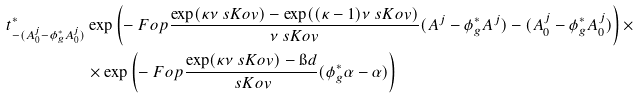<formula> <loc_0><loc_0><loc_500><loc_500>t ^ { * } _ { - ( A ^ { j } _ { 0 } - \phi _ { g } ^ { * } A ^ { j } _ { 0 } ) } & \exp \left ( - \ F o p { \frac { \exp ( \kappa \nu \ s K o v ) - \exp ( ( \kappa - 1 ) \nu \ s K o v ) } { \nu \ s K o v } ( A ^ { j } - \phi _ { g } ^ { * } A ^ { j } ) - ( A ^ { j } _ { 0 } - \phi _ { g } ^ { * } A ^ { j } _ { 0 } ) } \right ) \times \\ & \times \exp \left ( - \ F o p { \frac { \exp ( \kappa \nu \ s K o v ) - \i d } { \ s K o v } ( \phi _ { g } ^ { * } \alpha - \alpha ) } \right )</formula> 